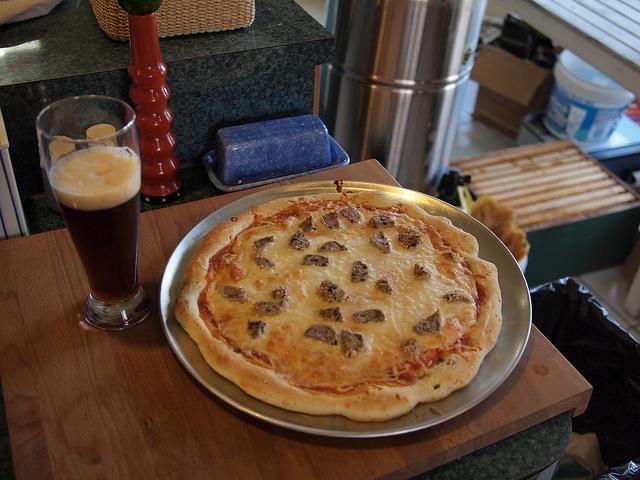What type of dish is the blue dish behind the pizza?
Be succinct. Butter. How many toppings are on the pizza?
Be succinct. 1. What kind of pizza is in the round pan?
Keep it brief. Sausage. Is there liquid in the glass?
Quick response, please. Yes. 